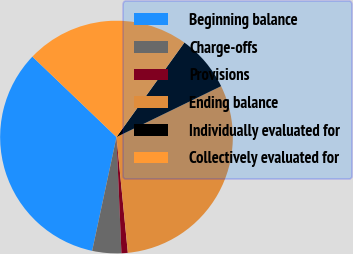Convert chart to OTSL. <chart><loc_0><loc_0><loc_500><loc_500><pie_chart><fcel>Beginning balance<fcel>Charge-offs<fcel>Provisions<fcel>Ending balance<fcel>Individually evaluated for<fcel>Collectively evaluated for<nl><fcel>33.8%<fcel>4.03%<fcel>0.88%<fcel>30.65%<fcel>7.88%<fcel>22.77%<nl></chart> 